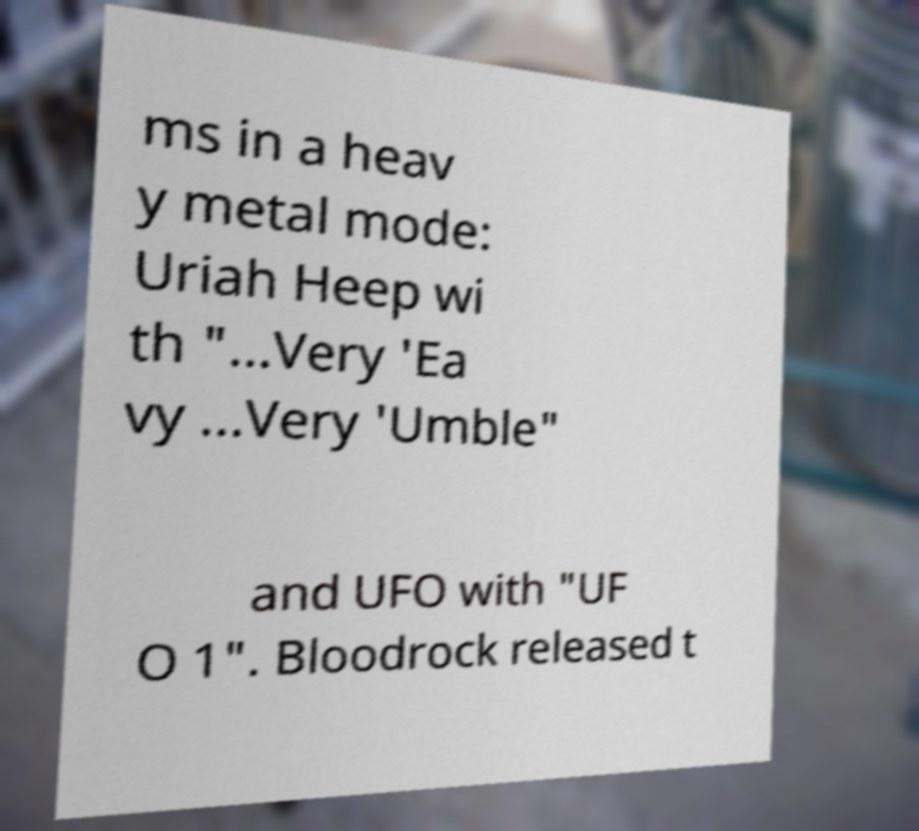There's text embedded in this image that I need extracted. Can you transcribe it verbatim? ms in a heav y metal mode: Uriah Heep wi th "...Very 'Ea vy ...Very 'Umble" and UFO with "UF O 1". Bloodrock released t 